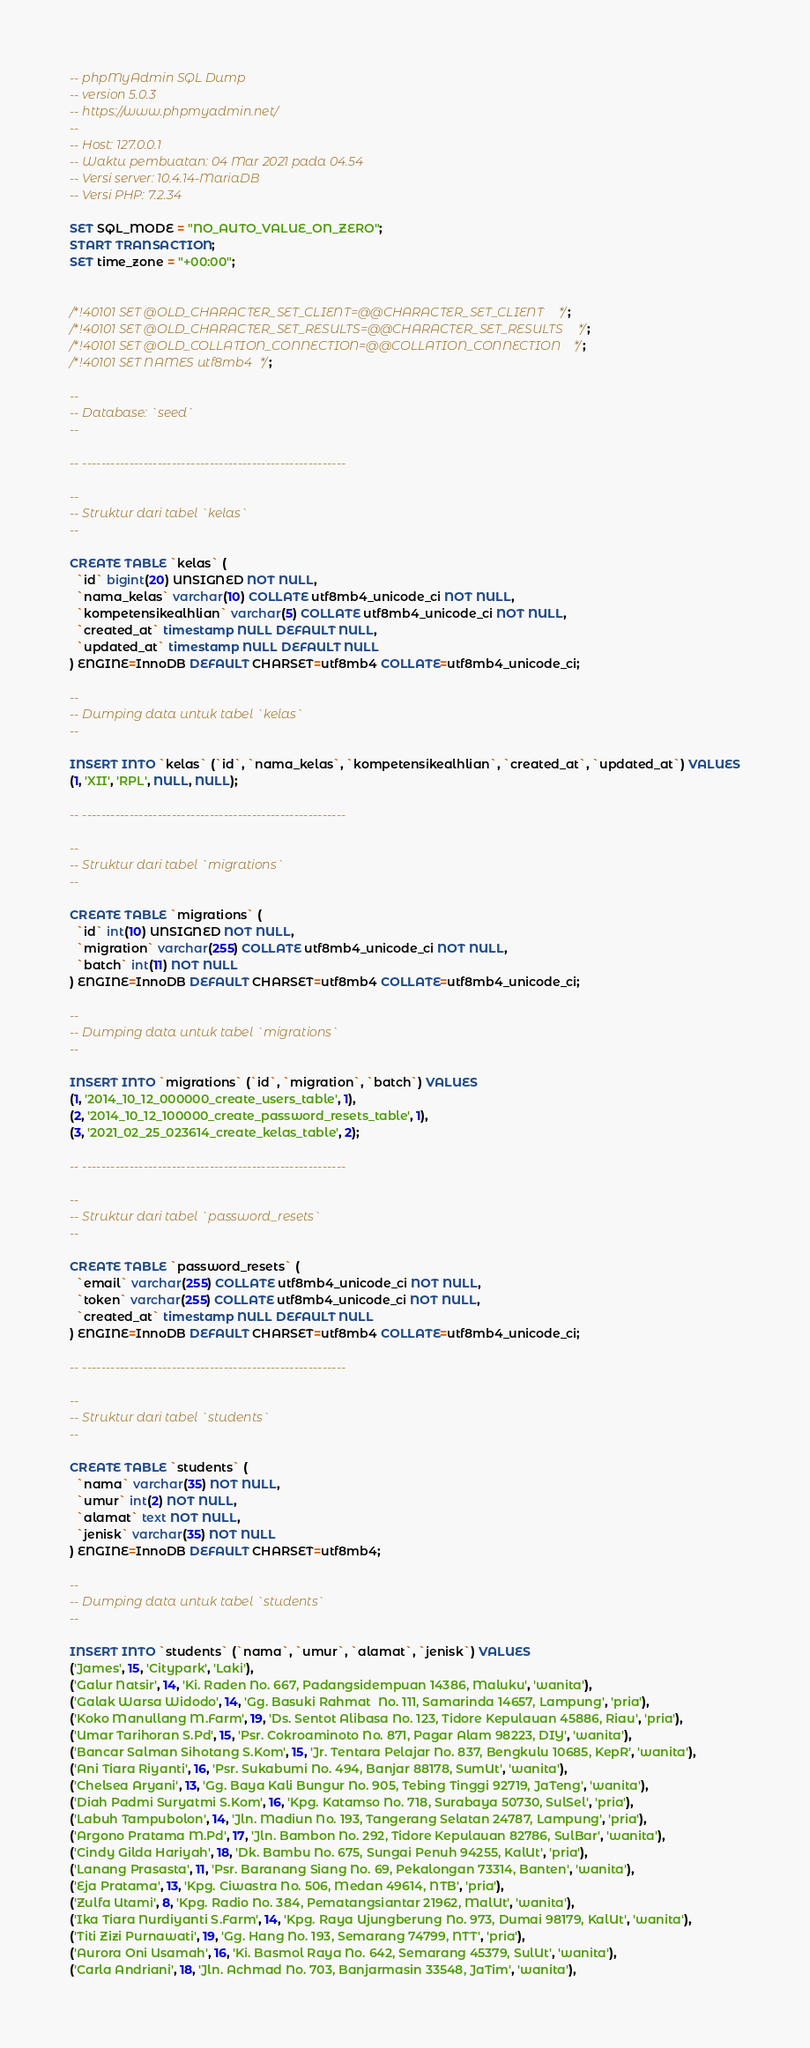Convert code to text. <code><loc_0><loc_0><loc_500><loc_500><_SQL_>-- phpMyAdmin SQL Dump
-- version 5.0.3
-- https://www.phpmyadmin.net/
--
-- Host: 127.0.0.1
-- Waktu pembuatan: 04 Mar 2021 pada 04.54
-- Versi server: 10.4.14-MariaDB
-- Versi PHP: 7.2.34

SET SQL_MODE = "NO_AUTO_VALUE_ON_ZERO";
START TRANSACTION;
SET time_zone = "+00:00";


/*!40101 SET @OLD_CHARACTER_SET_CLIENT=@@CHARACTER_SET_CLIENT */;
/*!40101 SET @OLD_CHARACTER_SET_RESULTS=@@CHARACTER_SET_RESULTS */;
/*!40101 SET @OLD_COLLATION_CONNECTION=@@COLLATION_CONNECTION */;
/*!40101 SET NAMES utf8mb4 */;

--
-- Database: `seed`
--

-- --------------------------------------------------------

--
-- Struktur dari tabel `kelas`
--

CREATE TABLE `kelas` (
  `id` bigint(20) UNSIGNED NOT NULL,
  `nama_kelas` varchar(10) COLLATE utf8mb4_unicode_ci NOT NULL,
  `kompetensikealhlian` varchar(5) COLLATE utf8mb4_unicode_ci NOT NULL,
  `created_at` timestamp NULL DEFAULT NULL,
  `updated_at` timestamp NULL DEFAULT NULL
) ENGINE=InnoDB DEFAULT CHARSET=utf8mb4 COLLATE=utf8mb4_unicode_ci;

--
-- Dumping data untuk tabel `kelas`
--

INSERT INTO `kelas` (`id`, `nama_kelas`, `kompetensikealhlian`, `created_at`, `updated_at`) VALUES
(1, 'XII', 'RPL', NULL, NULL);

-- --------------------------------------------------------

--
-- Struktur dari tabel `migrations`
--

CREATE TABLE `migrations` (
  `id` int(10) UNSIGNED NOT NULL,
  `migration` varchar(255) COLLATE utf8mb4_unicode_ci NOT NULL,
  `batch` int(11) NOT NULL
) ENGINE=InnoDB DEFAULT CHARSET=utf8mb4 COLLATE=utf8mb4_unicode_ci;

--
-- Dumping data untuk tabel `migrations`
--

INSERT INTO `migrations` (`id`, `migration`, `batch`) VALUES
(1, '2014_10_12_000000_create_users_table', 1),
(2, '2014_10_12_100000_create_password_resets_table', 1),
(3, '2021_02_25_023614_create_kelas_table', 2);

-- --------------------------------------------------------

--
-- Struktur dari tabel `password_resets`
--

CREATE TABLE `password_resets` (
  `email` varchar(255) COLLATE utf8mb4_unicode_ci NOT NULL,
  `token` varchar(255) COLLATE utf8mb4_unicode_ci NOT NULL,
  `created_at` timestamp NULL DEFAULT NULL
) ENGINE=InnoDB DEFAULT CHARSET=utf8mb4 COLLATE=utf8mb4_unicode_ci;

-- --------------------------------------------------------

--
-- Struktur dari tabel `students`
--

CREATE TABLE `students` (
  `nama` varchar(35) NOT NULL,
  `umur` int(2) NOT NULL,
  `alamat` text NOT NULL,
  `jenisk` varchar(35) NOT NULL
) ENGINE=InnoDB DEFAULT CHARSET=utf8mb4;

--
-- Dumping data untuk tabel `students`
--

INSERT INTO `students` (`nama`, `umur`, `alamat`, `jenisk`) VALUES
('James', 15, 'Citypark', 'Laki'),
('Galur Natsir', 14, 'Ki. Raden No. 667, Padangsidempuan 14386, Maluku', 'wanita'),
('Galak Warsa Widodo', 14, 'Gg. Basuki Rahmat  No. 111, Samarinda 14657, Lampung', 'pria'),
('Koko Manullang M.Farm', 19, 'Ds. Sentot Alibasa No. 123, Tidore Kepulauan 45886, Riau', 'pria'),
('Umar Tarihoran S.Pd', 15, 'Psr. Cokroaminoto No. 871, Pagar Alam 98223, DIY', 'wanita'),
('Bancar Salman Sihotang S.Kom', 15, 'Jr. Tentara Pelajar No. 837, Bengkulu 10685, KepR', 'wanita'),
('Ani Tiara Riyanti', 16, 'Psr. Sukabumi No. 494, Banjar 88178, SumUt', 'wanita'),
('Chelsea Aryani', 13, 'Gg. Baya Kali Bungur No. 905, Tebing Tinggi 92719, JaTeng', 'wanita'),
('Diah Padmi Suryatmi S.Kom', 16, 'Kpg. Katamso No. 718, Surabaya 50730, SulSel', 'pria'),
('Labuh Tampubolon', 14, 'Jln. Madiun No. 193, Tangerang Selatan 24787, Lampung', 'pria'),
('Argono Pratama M.Pd', 17, 'Jln. Bambon No. 292, Tidore Kepulauan 82786, SulBar', 'wanita'),
('Cindy Gilda Hariyah', 18, 'Dk. Bambu No. 675, Sungai Penuh 94255, KalUt', 'pria'),
('Lanang Prasasta', 11, 'Psr. Baranang Siang No. 69, Pekalongan 73314, Banten', 'wanita'),
('Eja Pratama', 13, 'Kpg. Ciwastra No. 506, Medan 49614, NTB', 'pria'),
('Zulfa Utami', 8, 'Kpg. Radio No. 384, Pematangsiantar 21962, MalUt', 'wanita'),
('Ika Tiara Nurdiyanti S.Farm', 14, 'Kpg. Raya Ujungberung No. 973, Dumai 98179, KalUt', 'wanita'),
('Titi Zizi Purnawati', 19, 'Gg. Hang No. 193, Semarang 74799, NTT', 'pria'),
('Aurora Oni Usamah', 16, 'Ki. Basmol Raya No. 642, Semarang 45379, SulUt', 'wanita'),
('Carla Andriani', 18, 'Jln. Achmad No. 703, Banjarmasin 33548, JaTim', 'wanita'),</code> 